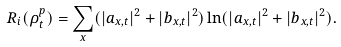Convert formula to latex. <formula><loc_0><loc_0><loc_500><loc_500>R _ { i } ( { \rho _ { t } ^ { p } } ) = \sum _ { x } ( | a _ { x , t } | ^ { 2 } + | b _ { x , t } | ^ { 2 } ) \ln ( | a _ { x , t } | ^ { 2 } + | b _ { x , t } | ^ { 2 } ) .</formula> 